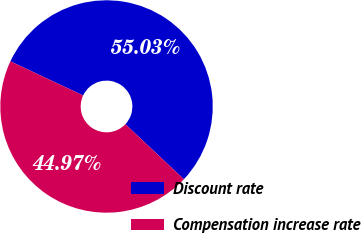Convert chart. <chart><loc_0><loc_0><loc_500><loc_500><pie_chart><fcel>Discount rate<fcel>Compensation increase rate<nl><fcel>55.03%<fcel>44.97%<nl></chart> 